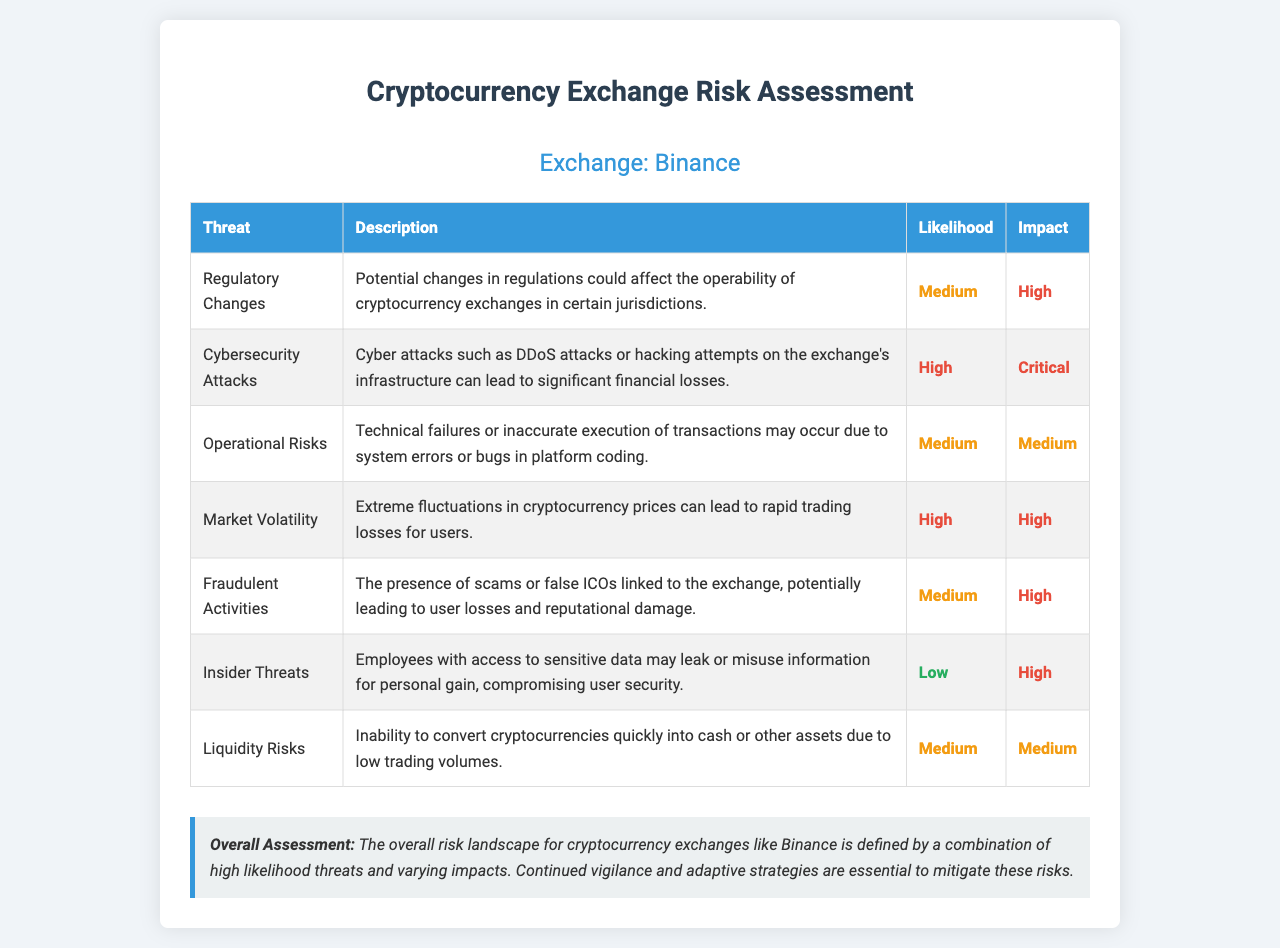What is the exchange name? The exchange name is stated at the top of the document, indicating the specific cryptocurrency exchange being assessed.
Answer: Binance How many threats are listed in the document? The document summarizes various threats to cryptocurrency exchanges, and by counting the entries, we can find the total.
Answer: 7 What is the likelihood rating for Cybersecurity Attacks? Each threat has an associated likelihood rating specified in the table, which helps gauge the frequency of the threat.
Answer: High What is the impact rating for Insider Threats? The impact rating is included for each listed threat, allowing for an understanding of the severity of potential consequences.
Answer: High What type of risk is associated with market volatility? The document categorizes various risks and provides descriptions for each, including their typical consequences.
Answer: Trading losses Which threat has a low likelihood rating? By reviewing the likelihood ratings, it is clear which threats are considered less likely to occur.
Answer: Insider Threats What is the overall assessment summarized at the end of the document? The summary reflects a holistic view of the risks identified in the assessment, drawing conclusions based on the listed threats.
Answer: High likelihood threats and varying impacts What type of attacks are mentioned under Cybersecurity Attacks? The document provides specific examples of threats under the category of Cybersecurity, illustrating the kinds of risks exchanges face.
Answer: DDoS attacks and hacking attempts What is the impact rating for Fraudulent Activities? Each threat is associated with an impact rating, providing insight into the repercussions if such activities occur.
Answer: High 